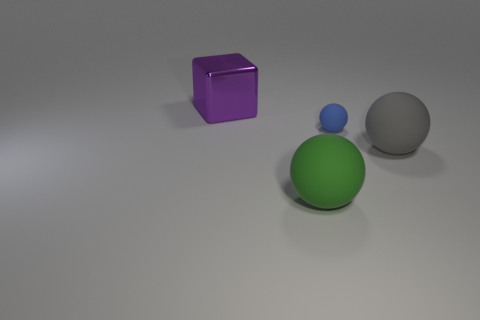Is there a large rubber sphere that has the same color as the metallic cube?
Your answer should be very brief. No. There is a large object that is on the right side of the green matte ball; how many matte objects are in front of it?
Make the answer very short. 1. What number of big gray objects are the same material as the big green ball?
Your answer should be compact. 1. How many big things are blue balls or green shiny balls?
Give a very brief answer. 0. There is a matte object that is to the left of the gray matte sphere and behind the big green thing; what shape is it?
Offer a terse response. Sphere. Are the large block and the small blue ball made of the same material?
Keep it short and to the point. No. There is a block that is the same size as the gray rubber ball; what color is it?
Provide a short and direct response. Purple. What color is the rubber object that is both in front of the tiny blue ball and behind the green rubber object?
Keep it short and to the point. Gray. There is a object on the left side of the object that is in front of the large rubber ball to the right of the large green rubber object; what size is it?
Your response must be concise. Large. What is the big green ball made of?
Your response must be concise. Rubber. 